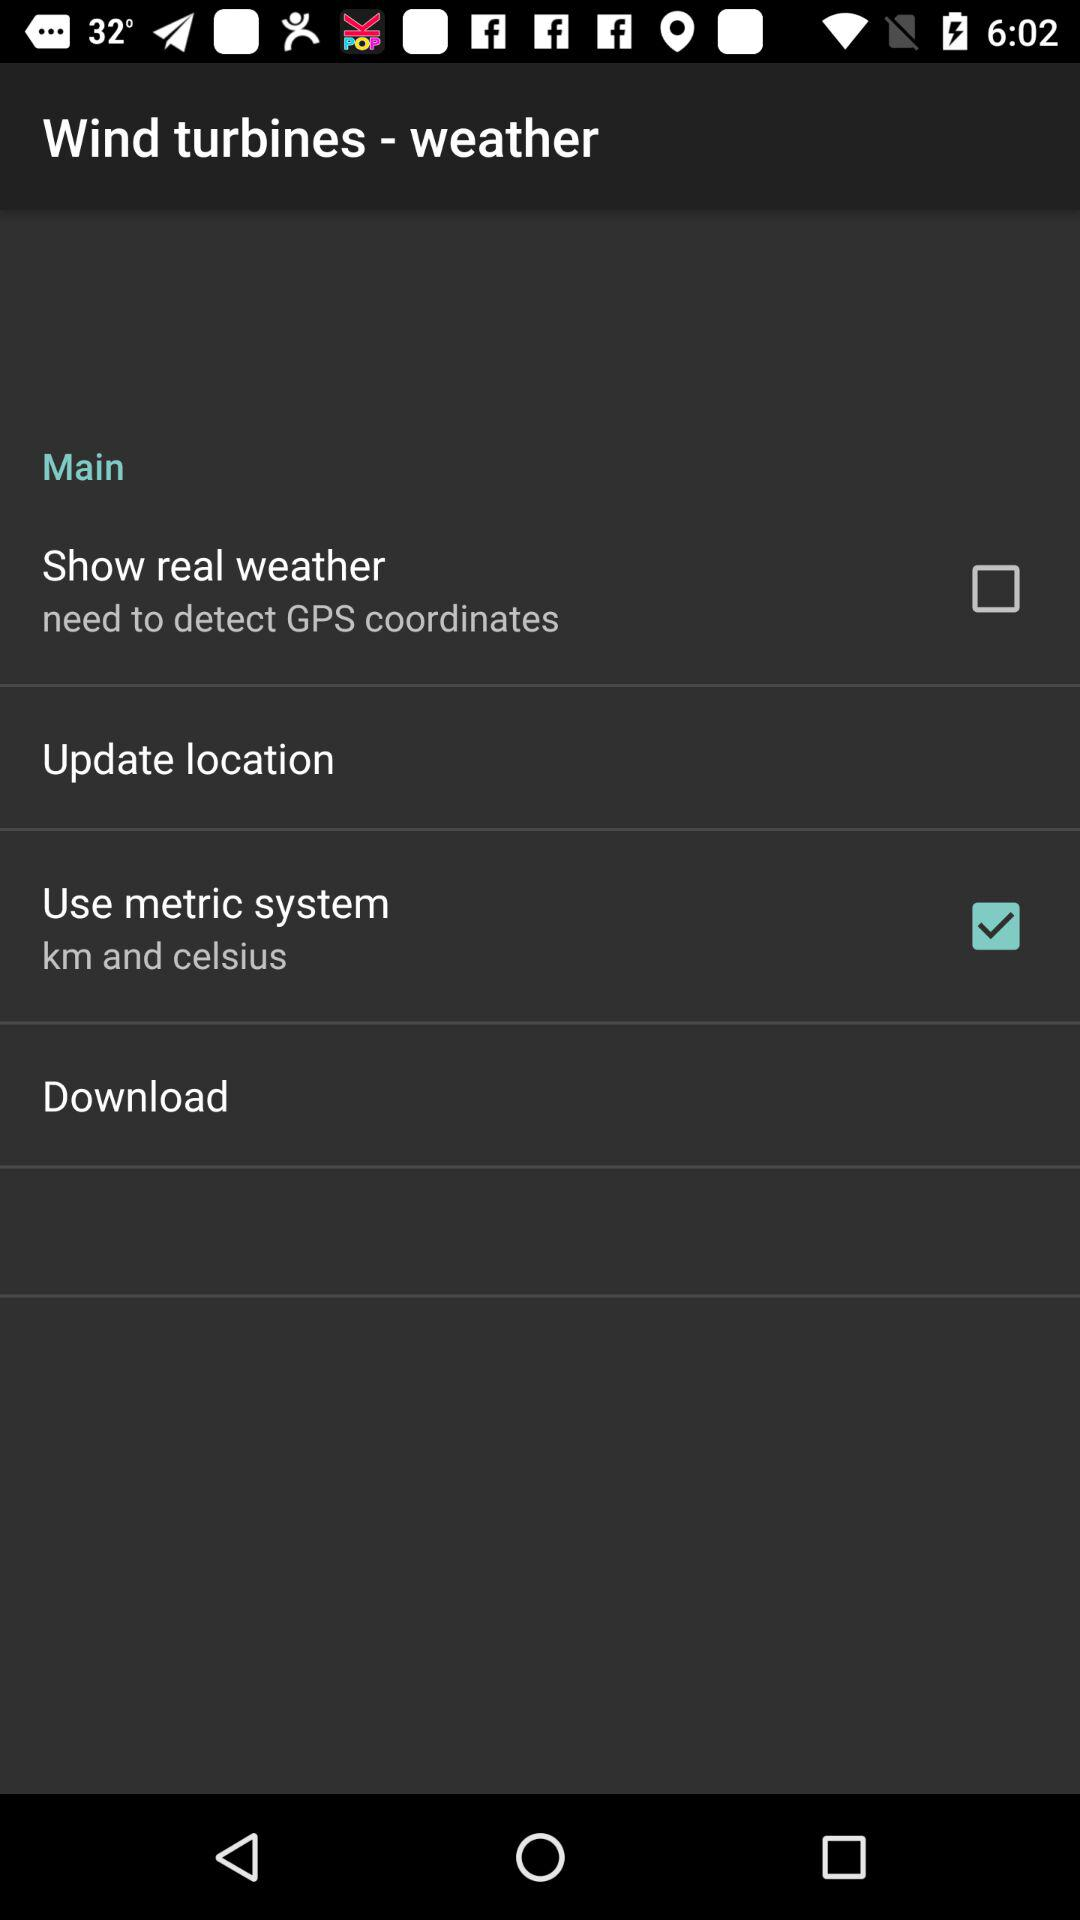What is the status of "Show real weather"? The status of "Show real weather" is "off". 